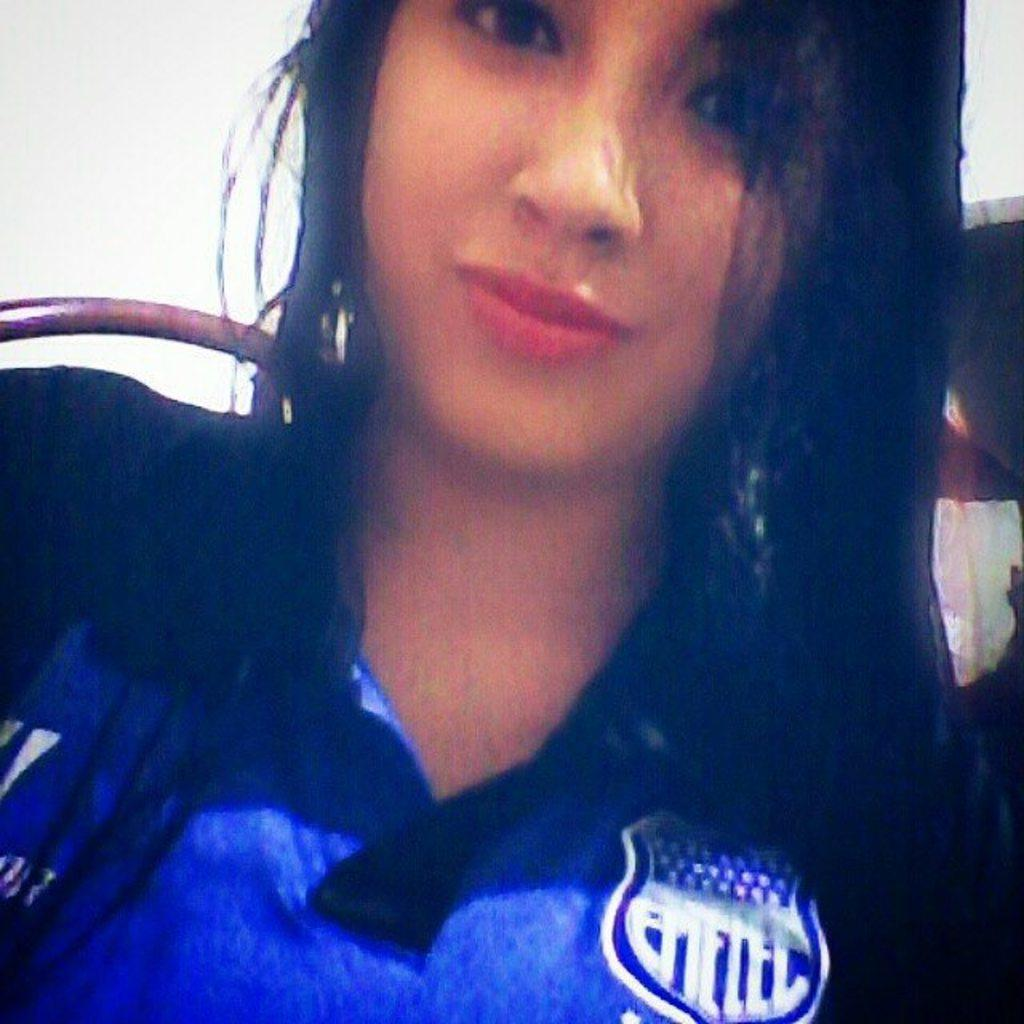Who is present in the image? There is a lady in the image. What can be seen behind the lady? The background of the image is white. What type of crack is visible on the plantation in the image? There is no crack or plantation present in the image; it only features a lady with a white background. 